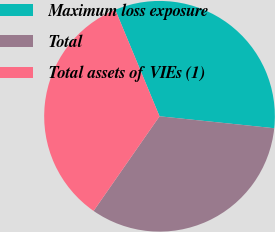Convert chart to OTSL. <chart><loc_0><loc_0><loc_500><loc_500><pie_chart><fcel>Maximum loss exposure<fcel>Total<fcel>Total assets of VIEs (1)<nl><fcel>32.92%<fcel>33.03%<fcel>34.05%<nl></chart> 